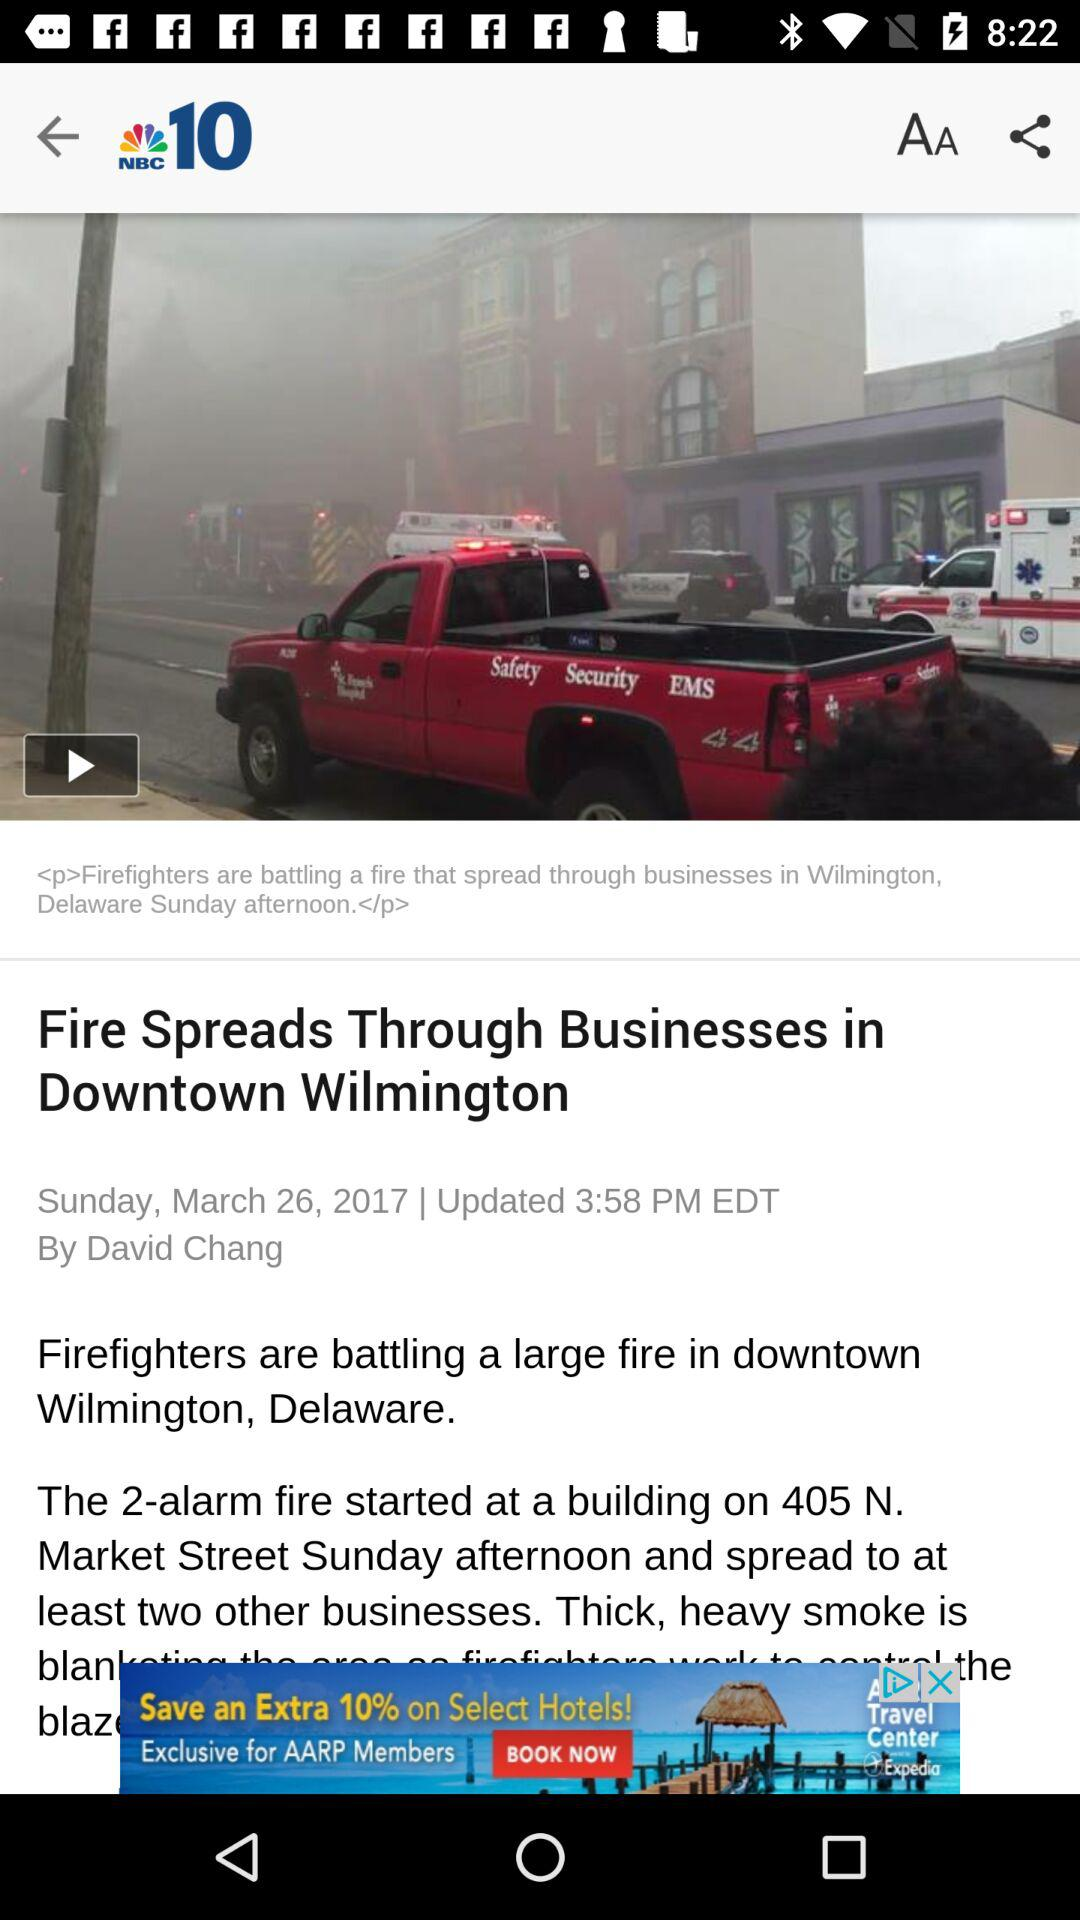Who is the writer of this article? The writer is David Chang. 